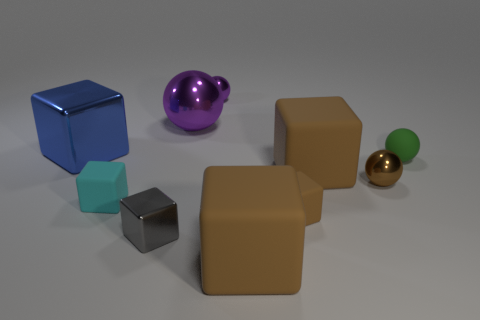Subtract all shiny cubes. How many cubes are left? 4 Subtract all blue blocks. How many blocks are left? 5 Subtract all blocks. How many objects are left? 4 Subtract 2 balls. How many balls are left? 2 Add 9 large blue objects. How many large blue objects exist? 10 Subtract 0 gray balls. How many objects are left? 10 Subtract all blue spheres. Subtract all yellow cubes. How many spheres are left? 4 Subtract all blue cylinders. How many blue cubes are left? 1 Subtract all big brown rubber objects. Subtract all metallic balls. How many objects are left? 5 Add 9 small purple balls. How many small purple balls are left? 10 